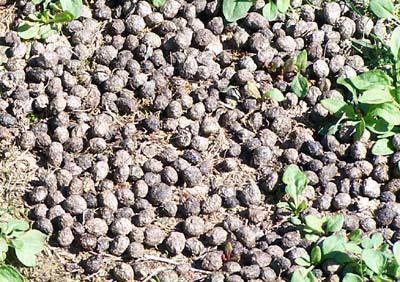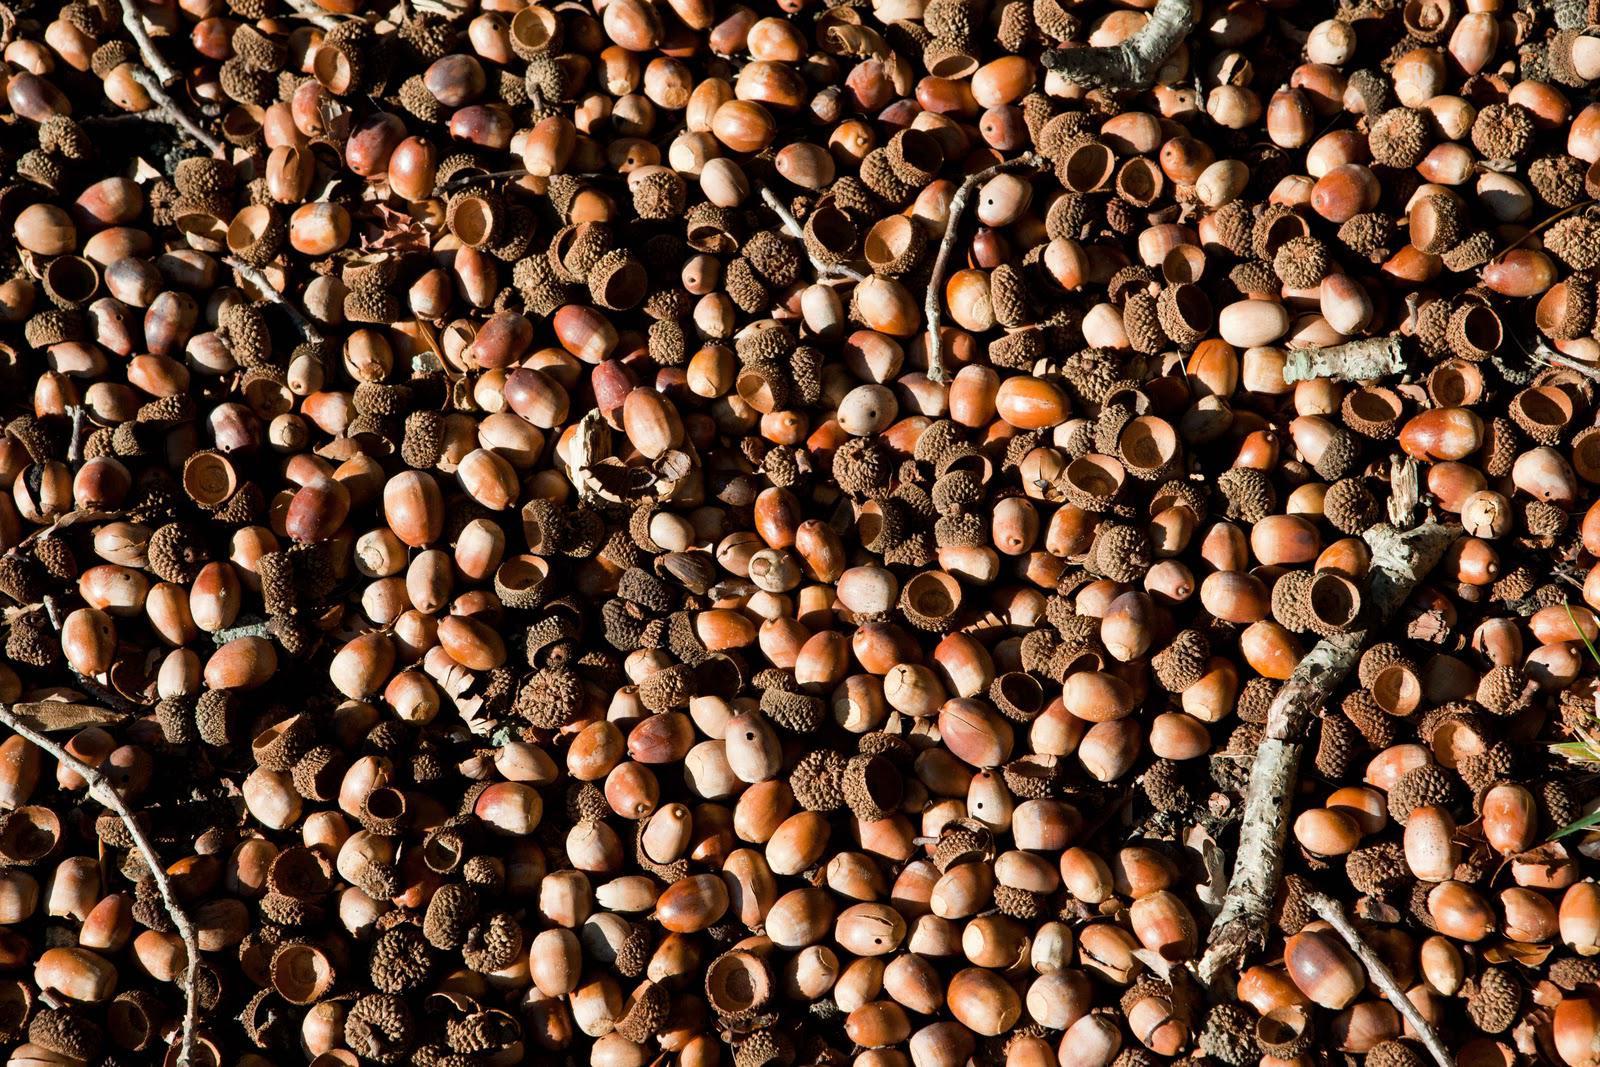The first image is the image on the left, the second image is the image on the right. Evaluate the accuracy of this statement regarding the images: "One image includes at least six recognizable autumn oak leaves amid a pile of fallen brown acorns and their separated caps.". Is it true? Answer yes or no. No. 